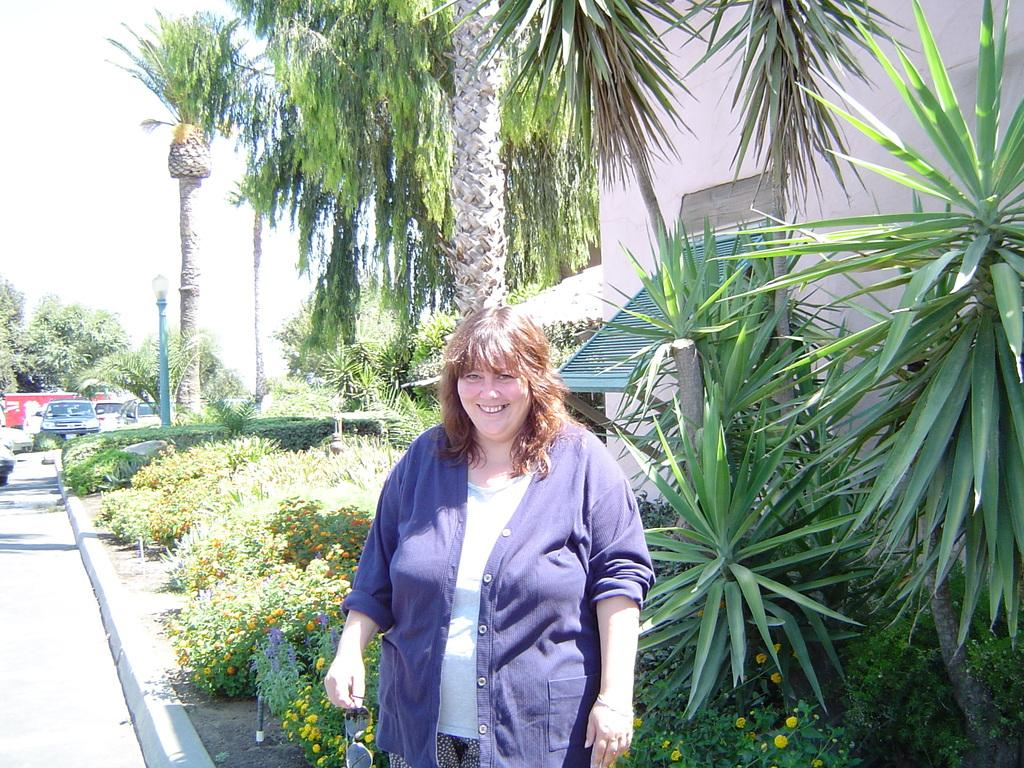Who is the main subject in the image? There is a woman in the image. What is the woman doing in the image? The woman is standing in front of a tree and smiling. What can be seen in the background of the image? There is a garden and vehicles in the background of the image. Can you see a giraffe in the garden in the background of the image? No, there is no giraffe present in the image. 